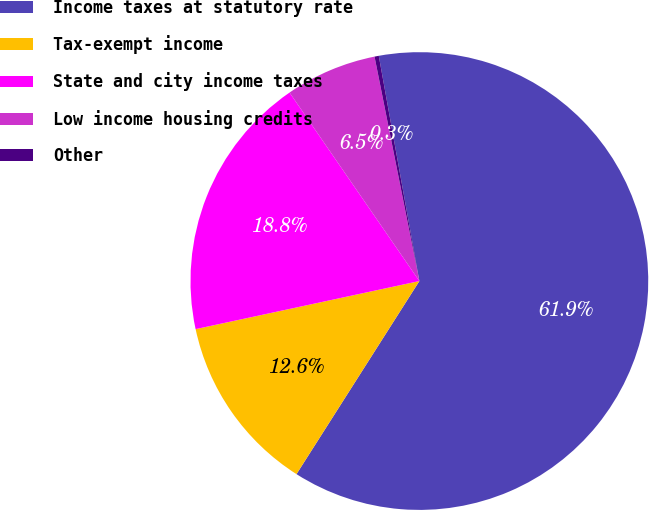<chart> <loc_0><loc_0><loc_500><loc_500><pie_chart><fcel>Income taxes at statutory rate<fcel>Tax-exempt income<fcel>State and city income taxes<fcel>Low income housing credits<fcel>Other<nl><fcel>61.86%<fcel>12.61%<fcel>18.77%<fcel>6.46%<fcel>0.3%<nl></chart> 